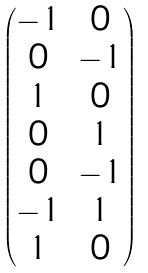Convert formula to latex. <formula><loc_0><loc_0><loc_500><loc_500>\begin{pmatrix} - 1 & 0 \\ 0 & - 1 \\ 1 & 0 \\ 0 & 1 \\ 0 & - 1 \\ - 1 & 1 \\ 1 & 0 \end{pmatrix}</formula> 